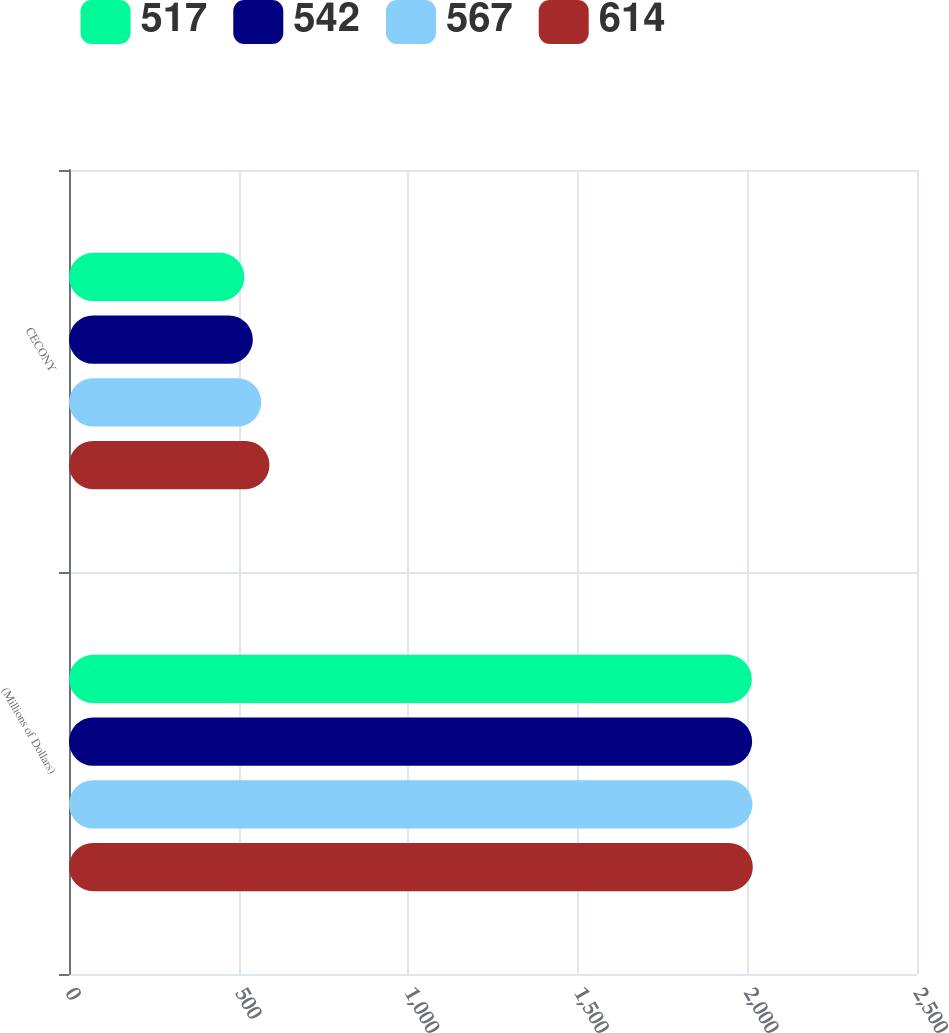Convert chart. <chart><loc_0><loc_0><loc_500><loc_500><stacked_bar_chart><ecel><fcel>(Millions of Dollars)<fcel>CECONY<nl><fcel>517<fcel>2013<fcel>517<nl><fcel>542<fcel>2014<fcel>542<nl><fcel>567<fcel>2015<fcel>567<nl><fcel>614<fcel>2016<fcel>591<nl></chart> 